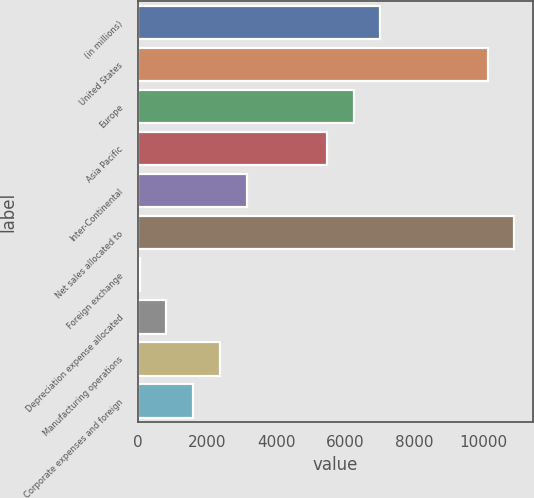Convert chart to OTSL. <chart><loc_0><loc_0><loc_500><loc_500><bar_chart><fcel>(in millions)<fcel>United States<fcel>Europe<fcel>Asia Pacific<fcel>Inter-Continental<fcel>Net sales allocated to<fcel>Foreign exchange<fcel>Depreciation expense allocated<fcel>Manufacturing operations<fcel>Corporate expenses and foreign<nl><fcel>7008.5<fcel>10106.5<fcel>6234<fcel>5459.5<fcel>3136<fcel>10881<fcel>38<fcel>812.5<fcel>2361.5<fcel>1587<nl></chart> 